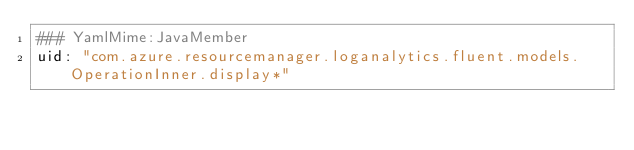<code> <loc_0><loc_0><loc_500><loc_500><_YAML_>### YamlMime:JavaMember
uid: "com.azure.resourcemanager.loganalytics.fluent.models.OperationInner.display*"</code> 